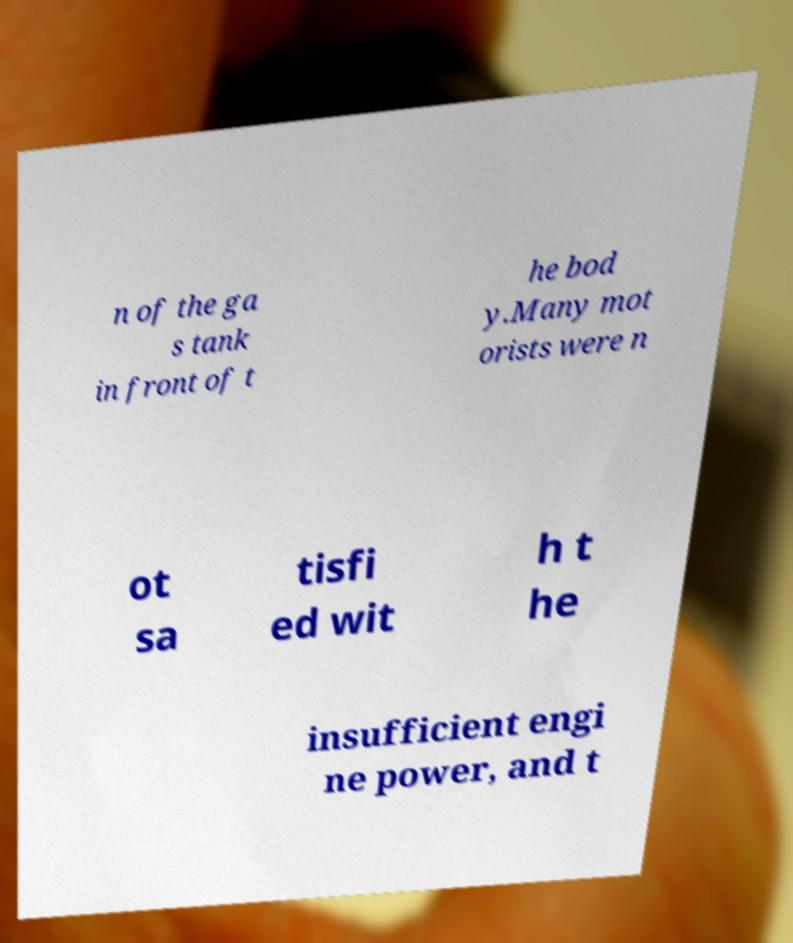What messages or text are displayed in this image? I need them in a readable, typed format. n of the ga s tank in front of t he bod y.Many mot orists were n ot sa tisfi ed wit h t he insufficient engi ne power, and t 